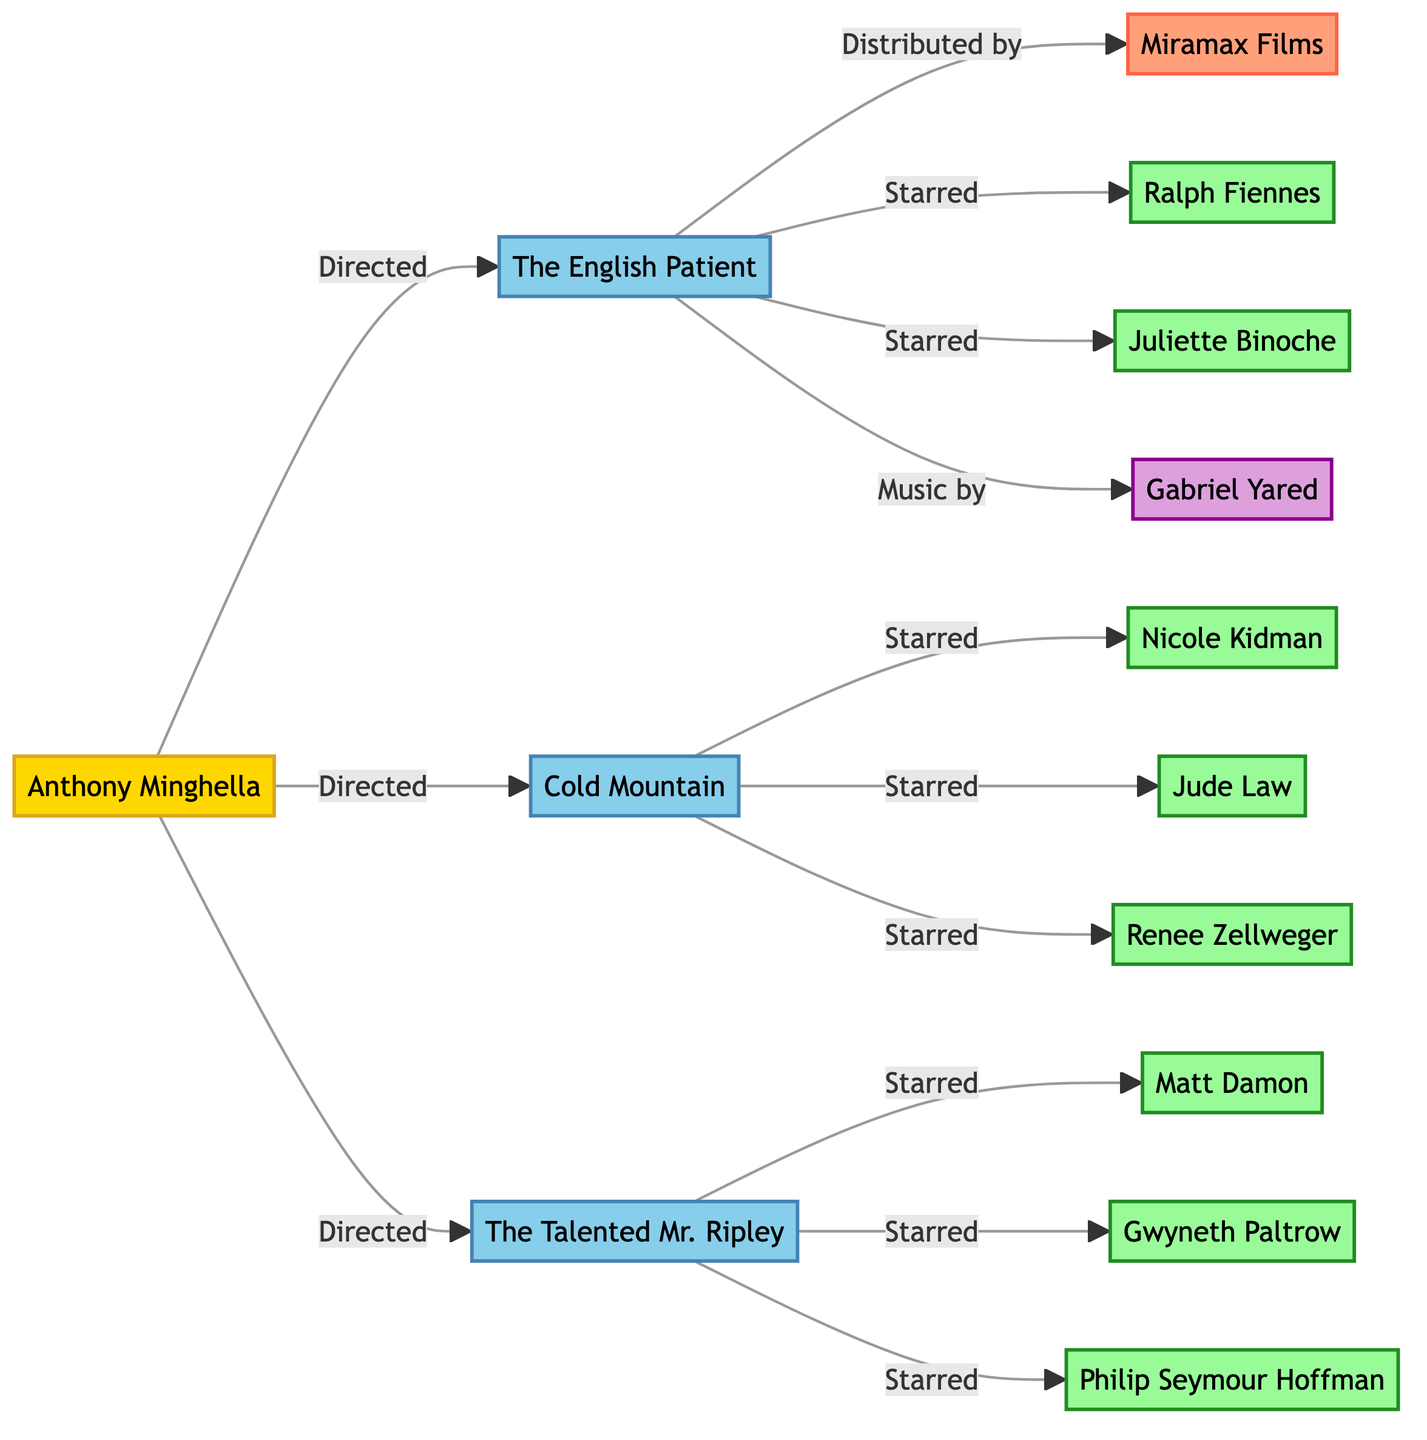What movie did Anthony Minghella direct? The diagram indicates that Anthony Minghella directed "The English Patient," "Cold Mountain," and "The Talented Mr. Ripley."
Answer: The English Patient How many movies are listed in the diagram? By counting the nodes labeled as movies, there are three distinct movies represented: "The English Patient," "Cold Mountain," and "The Talented Mr. Ripley."
Answer: 3 Which studio distributed "The English Patient"? The diagram shows an edge labeled "Distributed by" leading from "The English Patient" to "Miramax Films," indicating that the studio responsible for distribution is Miramax Films.
Answer: Miramax Films Who starred in "Cold Mountain"? The diagram indicates three edges from "Cold Mountain" connecting to three actors: "Nicole Kidman," "Jude Law," and "Renee Zellweger," who all starred in the film.
Answer: Nicole Kidman, Jude Law, Renee Zellweger What is the relationship between "The English Patient" and "Gabriel Yared"? There is an edge labeled "Music by" connecting "The English Patient" to "Gabriel Yared," indicating that Gabriel Yared composed the music for the film.
Answer: Music by How many actors starred in "The Talented Mr. Ripley"? The diagram shows three edges from "The Talented Mr. Ripley" connecting to "Matt Damon," "Gwyneth Paltrow," and "Philip Seymour Hoffman," denoting that three actors starred in the film.
Answer: 3 Which actor starred in both "The English Patient" and "The Talented Mr. Ripley"? By examining the edges, "Ralph Fiennes" is connected to "The English Patient" with an edge labeled "Starred," while he is not connected to "The Talented Mr. Ripley." Hence, there isn't an actor who starred in both.
Answer: None Who collaborated with Anthony Minghella on the film "Cold Mountain"? Analyzing the edges linked to "Cold Mountain," it is revealed that "Nicole Kidman," "Jude Law," and "Renee Zellweger" starred alongside Anthony Minghella in this directed project.
Answer: Nicole Kidman, Jude Law, Renee Zellweger What role did Ralph Fiennes play in "The English Patient"? The edge labeled "Starred" connects "The English Patient" to "Ralph Fiennes," indicating he played a starring role in this movie directed by Anthony Minghella.
Answer: Starred 